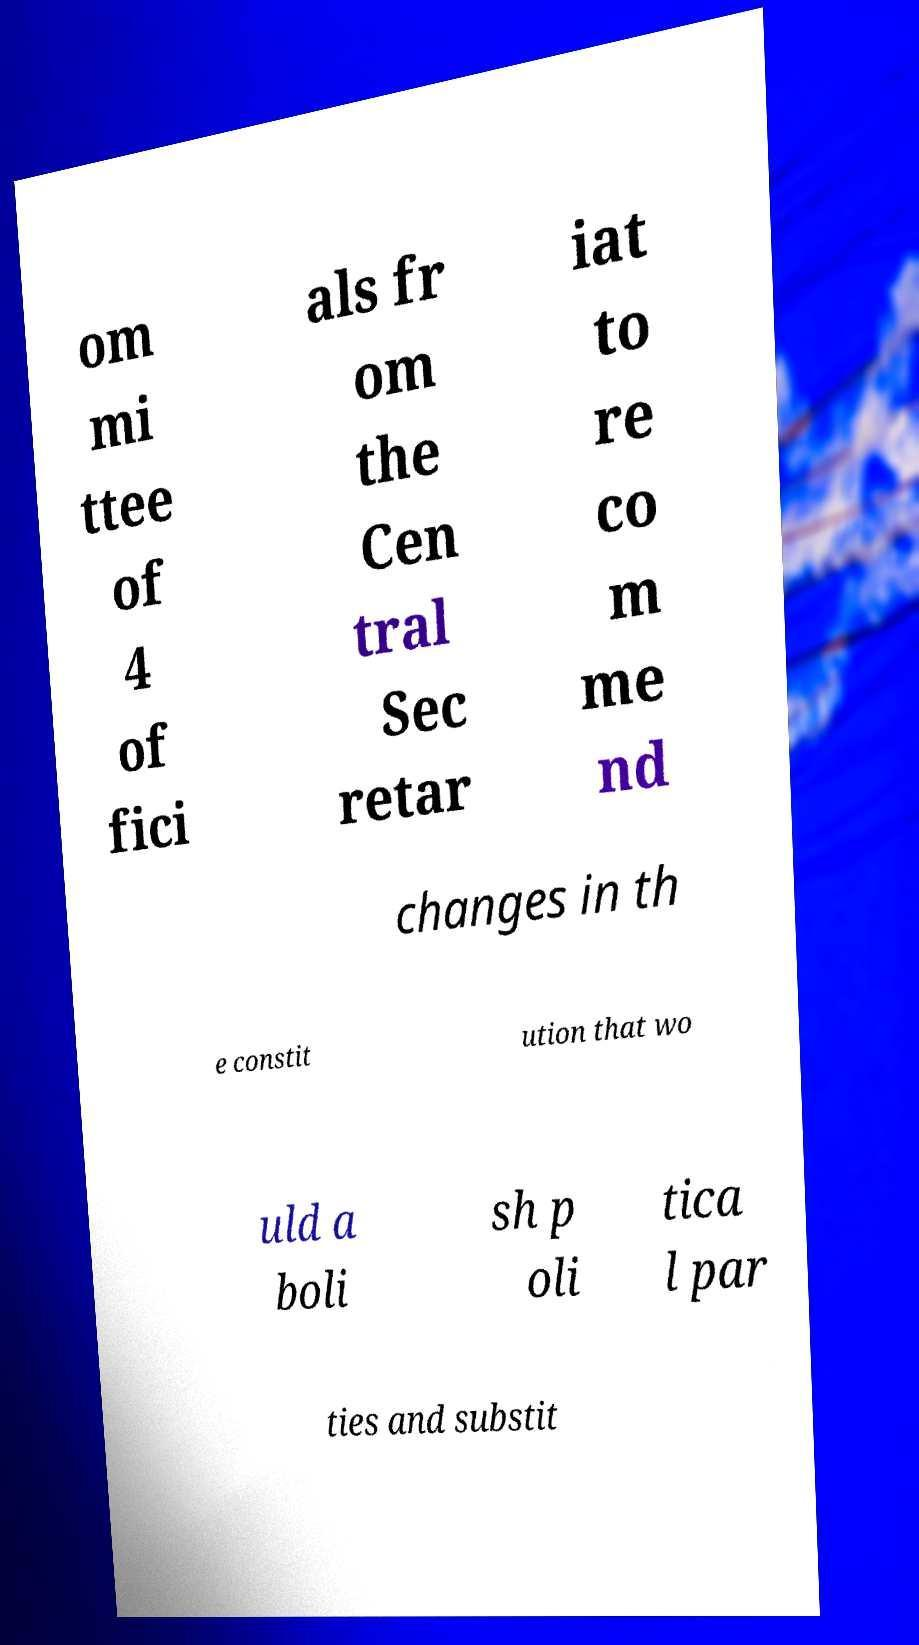There's text embedded in this image that I need extracted. Can you transcribe it verbatim? om mi ttee of 4 of fici als fr om the Cen tral Sec retar iat to re co m me nd changes in th e constit ution that wo uld a boli sh p oli tica l par ties and substit 